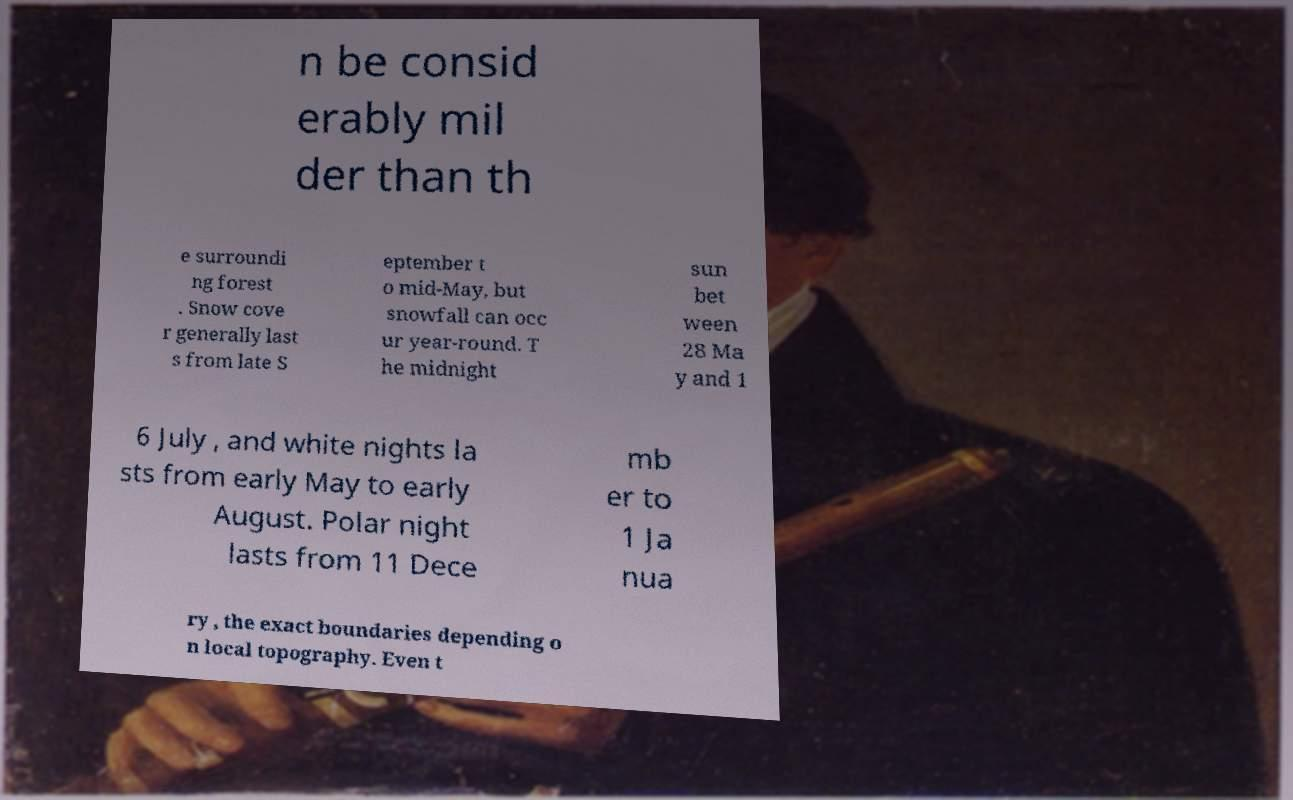Please identify and transcribe the text found in this image. n be consid erably mil der than th e surroundi ng forest . Snow cove r generally last s from late S eptember t o mid-May, but snowfall can occ ur year-round. T he midnight sun bet ween 28 Ma y and 1 6 July , and white nights la sts from early May to early August. Polar night lasts from 11 Dece mb er to 1 Ja nua ry , the exact boundaries depending o n local topography. Even t 